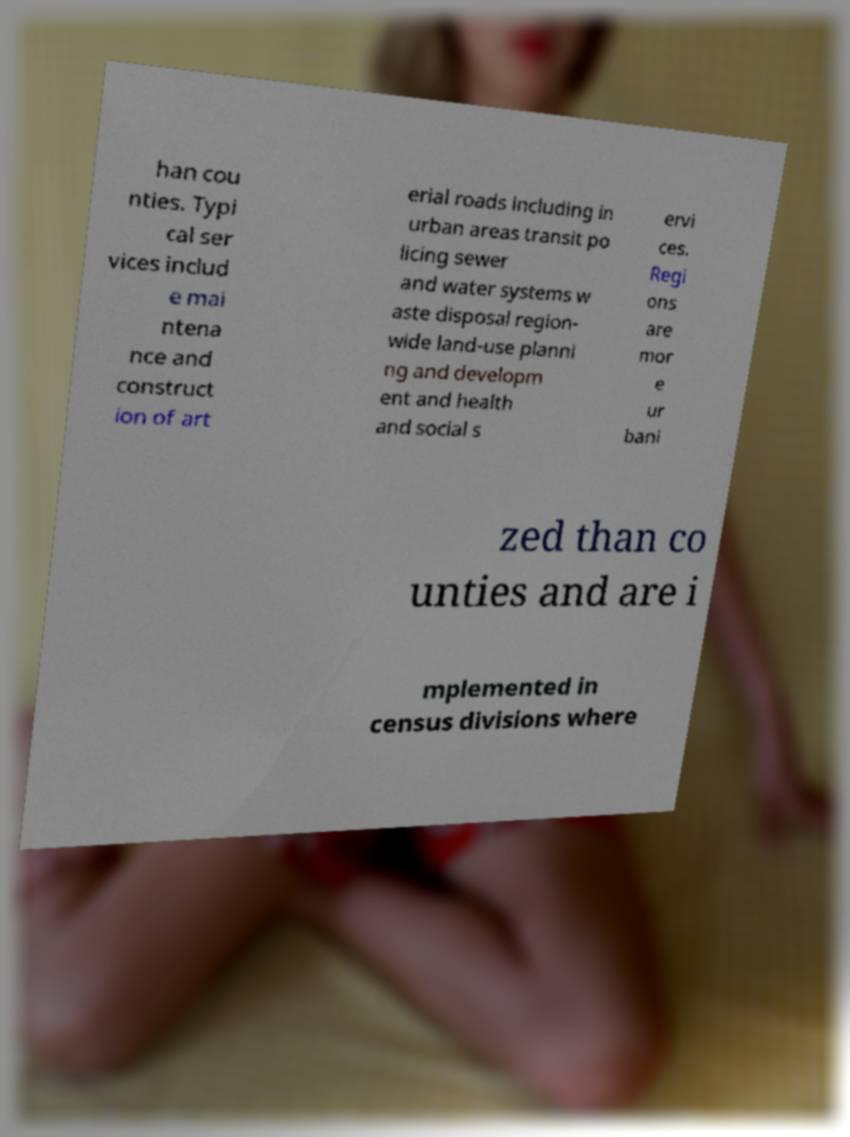What messages or text are displayed in this image? I need them in a readable, typed format. han cou nties. Typi cal ser vices includ e mai ntena nce and construct ion of art erial roads including in urban areas transit po licing sewer and water systems w aste disposal region- wide land-use planni ng and developm ent and health and social s ervi ces. Regi ons are mor e ur bani zed than co unties and are i mplemented in census divisions where 